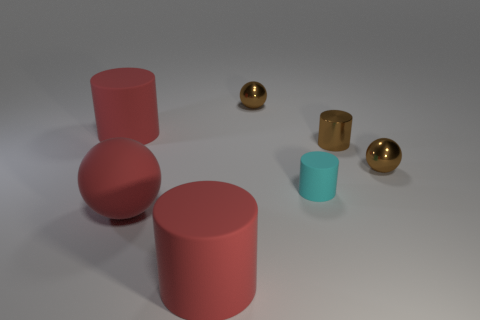How many spheres are in front of the tiny cyan cylinder and right of the small cyan matte object?
Make the answer very short. 0. How many red objects are either matte cylinders or tiny matte things?
Provide a short and direct response. 2. How many metal things are red balls or large red objects?
Your response must be concise. 0. Are there any large cylinders?
Keep it short and to the point. Yes. There is a tiny cyan matte cylinder in front of the small brown metal object on the left side of the tiny matte thing; what number of brown shiny objects are left of it?
Give a very brief answer. 1. There is a object that is in front of the small brown metal cylinder and behind the small rubber cylinder; what is it made of?
Provide a succinct answer. Metal. What color is the thing that is both right of the rubber sphere and behind the brown cylinder?
Offer a very short reply. Brown. Are there any other things that are the same color as the small matte cylinder?
Your response must be concise. No. What shape is the large red thing that is behind the tiny cyan rubber object that is right of the big cylinder that is in front of the tiny cyan cylinder?
Your answer should be compact. Cylinder. What is the color of the other small metallic object that is the same shape as the tiny cyan object?
Provide a short and direct response. Brown. 